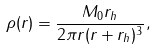Convert formula to latex. <formula><loc_0><loc_0><loc_500><loc_500>\rho ( r ) = \frac { M _ { 0 } r _ { h } } { 2 \pi r ( r + r _ { h } ) ^ { 3 } } ,</formula> 